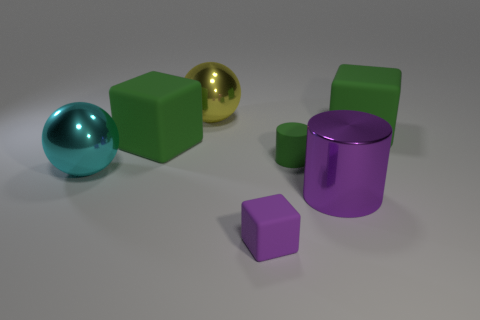Add 1 small cubes. How many objects exist? 8 Subtract all spheres. How many objects are left? 5 Subtract all big blocks. Subtract all big metallic things. How many objects are left? 2 Add 1 tiny purple things. How many tiny purple things are left? 2 Add 6 large cyan metal cylinders. How many large cyan metal cylinders exist? 6 Subtract 0 gray cylinders. How many objects are left? 7 